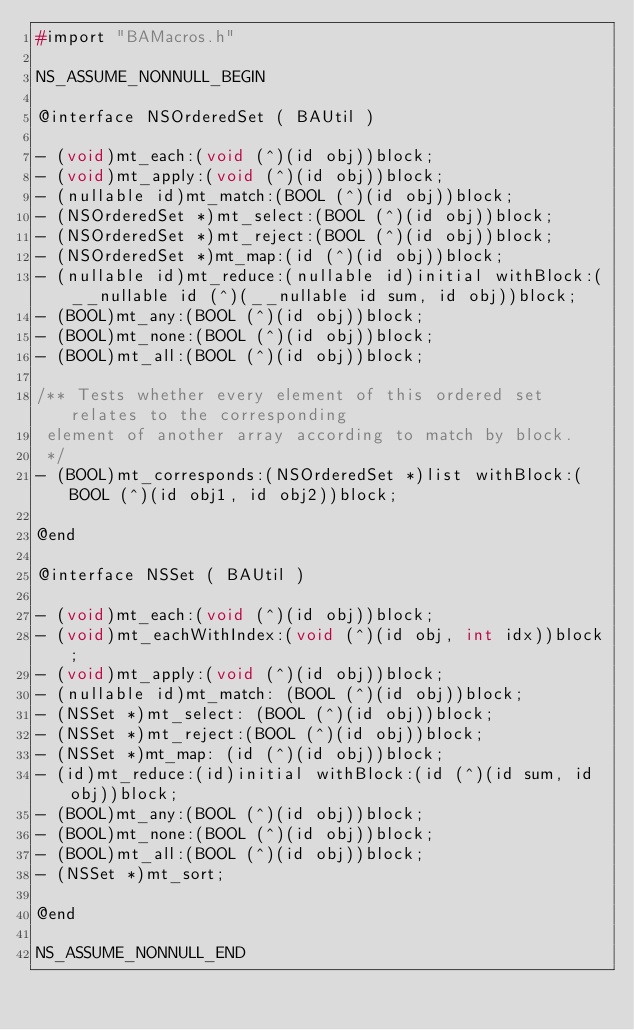<code> <loc_0><loc_0><loc_500><loc_500><_C_>#import "BAMacros.h"

NS_ASSUME_NONNULL_BEGIN

@interface NSOrderedSet ( BAUtil )

- (void)mt_each:(void (^)(id obj))block;
- (void)mt_apply:(void (^)(id obj))block;
- (nullable id)mt_match:(BOOL (^)(id obj))block;
- (NSOrderedSet *)mt_select:(BOOL (^)(id obj))block;
- (NSOrderedSet *)mt_reject:(BOOL (^)(id obj))block;
- (NSOrderedSet *)mt_map:(id (^)(id obj))block;
- (nullable id)mt_reduce:(nullable id)initial withBlock:(__nullable id (^)(__nullable id sum, id obj))block;
- (BOOL)mt_any:(BOOL (^)(id obj))block;
- (BOOL)mt_none:(BOOL (^)(id obj))block;
- (BOOL)mt_all:(BOOL (^)(id obj))block;

/** Tests whether every element of this ordered set relates to the corresponding
 element of another array according to match by block.
 */
- (BOOL)mt_corresponds:(NSOrderedSet *)list withBlock:(BOOL (^)(id obj1, id obj2))block;

@end

@interface NSSet ( BAUtil )

- (void)mt_each:(void (^)(id obj))block;
- (void)mt_eachWithIndex:(void (^)(id obj, int idx))block;
- (void)mt_apply:(void (^)(id obj))block;
- (nullable id)mt_match: (BOOL (^)(id obj))block;
- (NSSet *)mt_select: (BOOL (^)(id obj))block;
- (NSSet *)mt_reject:(BOOL (^)(id obj))block;
- (NSSet *)mt_map: (id (^)(id obj))block;
- (id)mt_reduce:(id)initial withBlock:(id (^)(id sum, id obj))block;
- (BOOL)mt_any:(BOOL (^)(id obj))block;
- (BOOL)mt_none:(BOOL (^)(id obj))block;
- (BOOL)mt_all:(BOOL (^)(id obj))block;
- (NSSet *)mt_sort;

@end

NS_ASSUME_NONNULL_END

</code> 